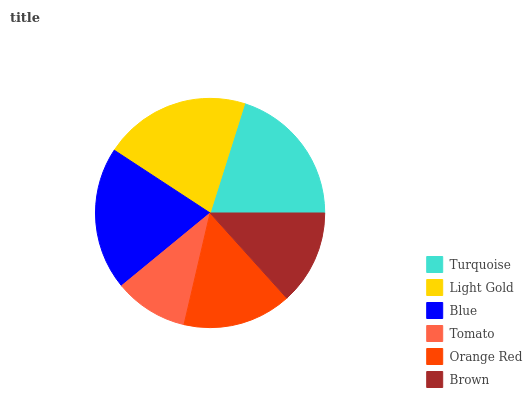Is Tomato the minimum?
Answer yes or no. Yes. Is Light Gold the maximum?
Answer yes or no. Yes. Is Blue the minimum?
Answer yes or no. No. Is Blue the maximum?
Answer yes or no. No. Is Light Gold greater than Blue?
Answer yes or no. Yes. Is Blue less than Light Gold?
Answer yes or no. Yes. Is Blue greater than Light Gold?
Answer yes or no. No. Is Light Gold less than Blue?
Answer yes or no. No. Is Turquoise the high median?
Answer yes or no. Yes. Is Orange Red the low median?
Answer yes or no. Yes. Is Light Gold the high median?
Answer yes or no. No. Is Brown the low median?
Answer yes or no. No. 